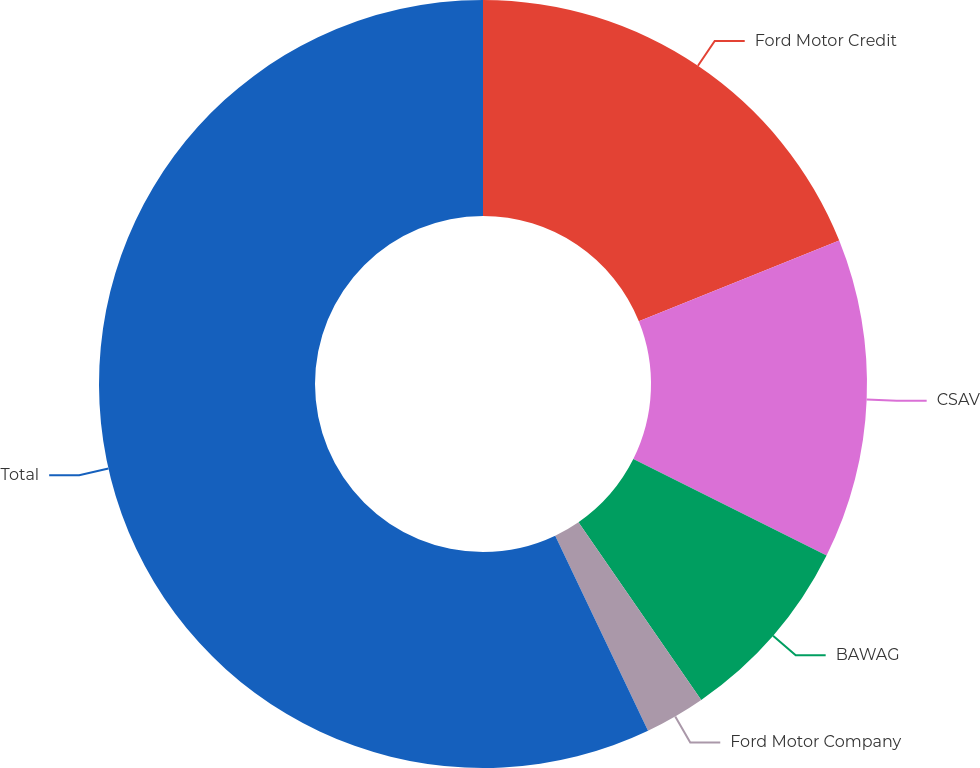<chart> <loc_0><loc_0><loc_500><loc_500><pie_chart><fcel>Ford Motor Credit<fcel>CSAV<fcel>BAWAG<fcel>Ford Motor Company<fcel>Total<nl><fcel>18.91%<fcel>13.46%<fcel>8.01%<fcel>2.55%<fcel>57.07%<nl></chart> 